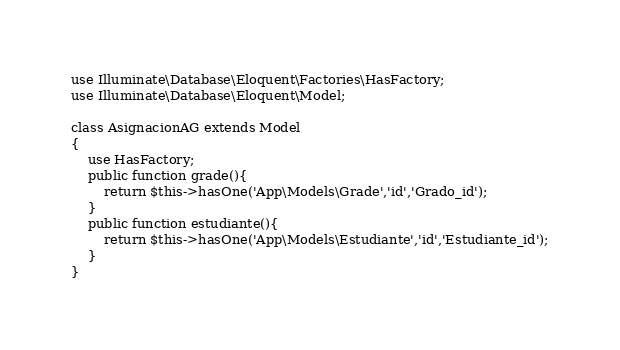<code> <loc_0><loc_0><loc_500><loc_500><_PHP_>use Illuminate\Database\Eloquent\Factories\HasFactory;
use Illuminate\Database\Eloquent\Model;

class AsignacionAG extends Model
{
    use HasFactory;
    public function grade(){
        return $this->hasOne('App\Models\Grade','id','Grado_id');
    }
    public function estudiante(){
        return $this->hasOne('App\Models\Estudiante','id','Estudiante_id');
    }
}
</code> 